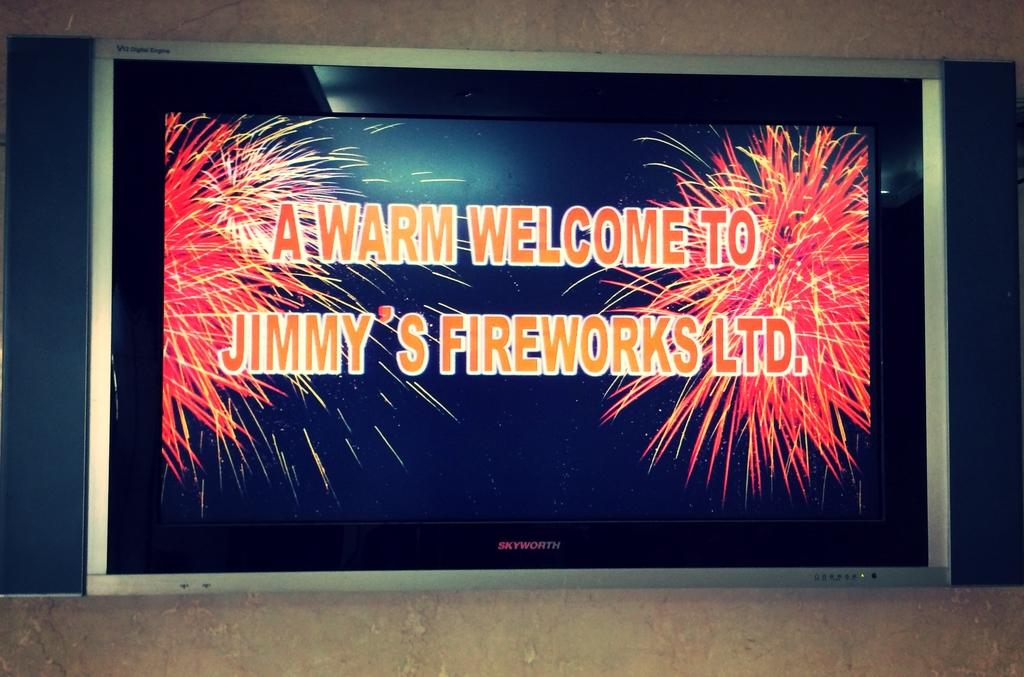<image>
Give a short and clear explanation of the subsequent image. A Skyworth brand flatscreen display with a welcome to Jimmy's Fireworks on the screen. 